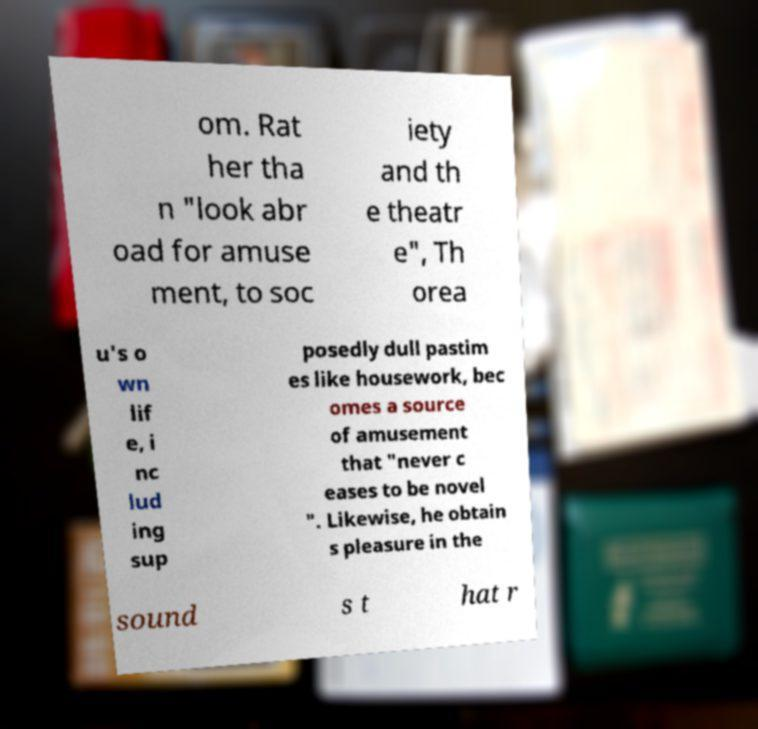Please read and relay the text visible in this image. What does it say? om. Rat her tha n "look abr oad for amuse ment, to soc iety and th e theatr e", Th orea u's o wn lif e, i nc lud ing sup posedly dull pastim es like housework, bec omes a source of amusement that "never c eases to be novel ". Likewise, he obtain s pleasure in the sound s t hat r 